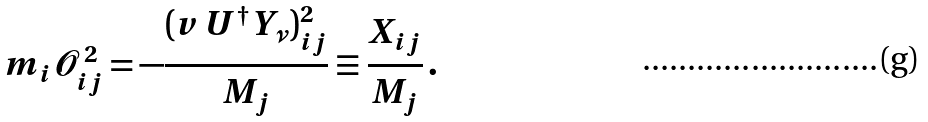Convert formula to latex. <formula><loc_0><loc_0><loc_500><loc_500>m _ { i } \mathcal { O } _ { i j } ^ { \, 2 } = - \frac { ( v \, U ^ { \dagger } Y _ { \nu } ) ^ { 2 } _ { i j } } { M _ { j } } \equiv \frac { X _ { i j } } { M _ { j } } \, .</formula> 